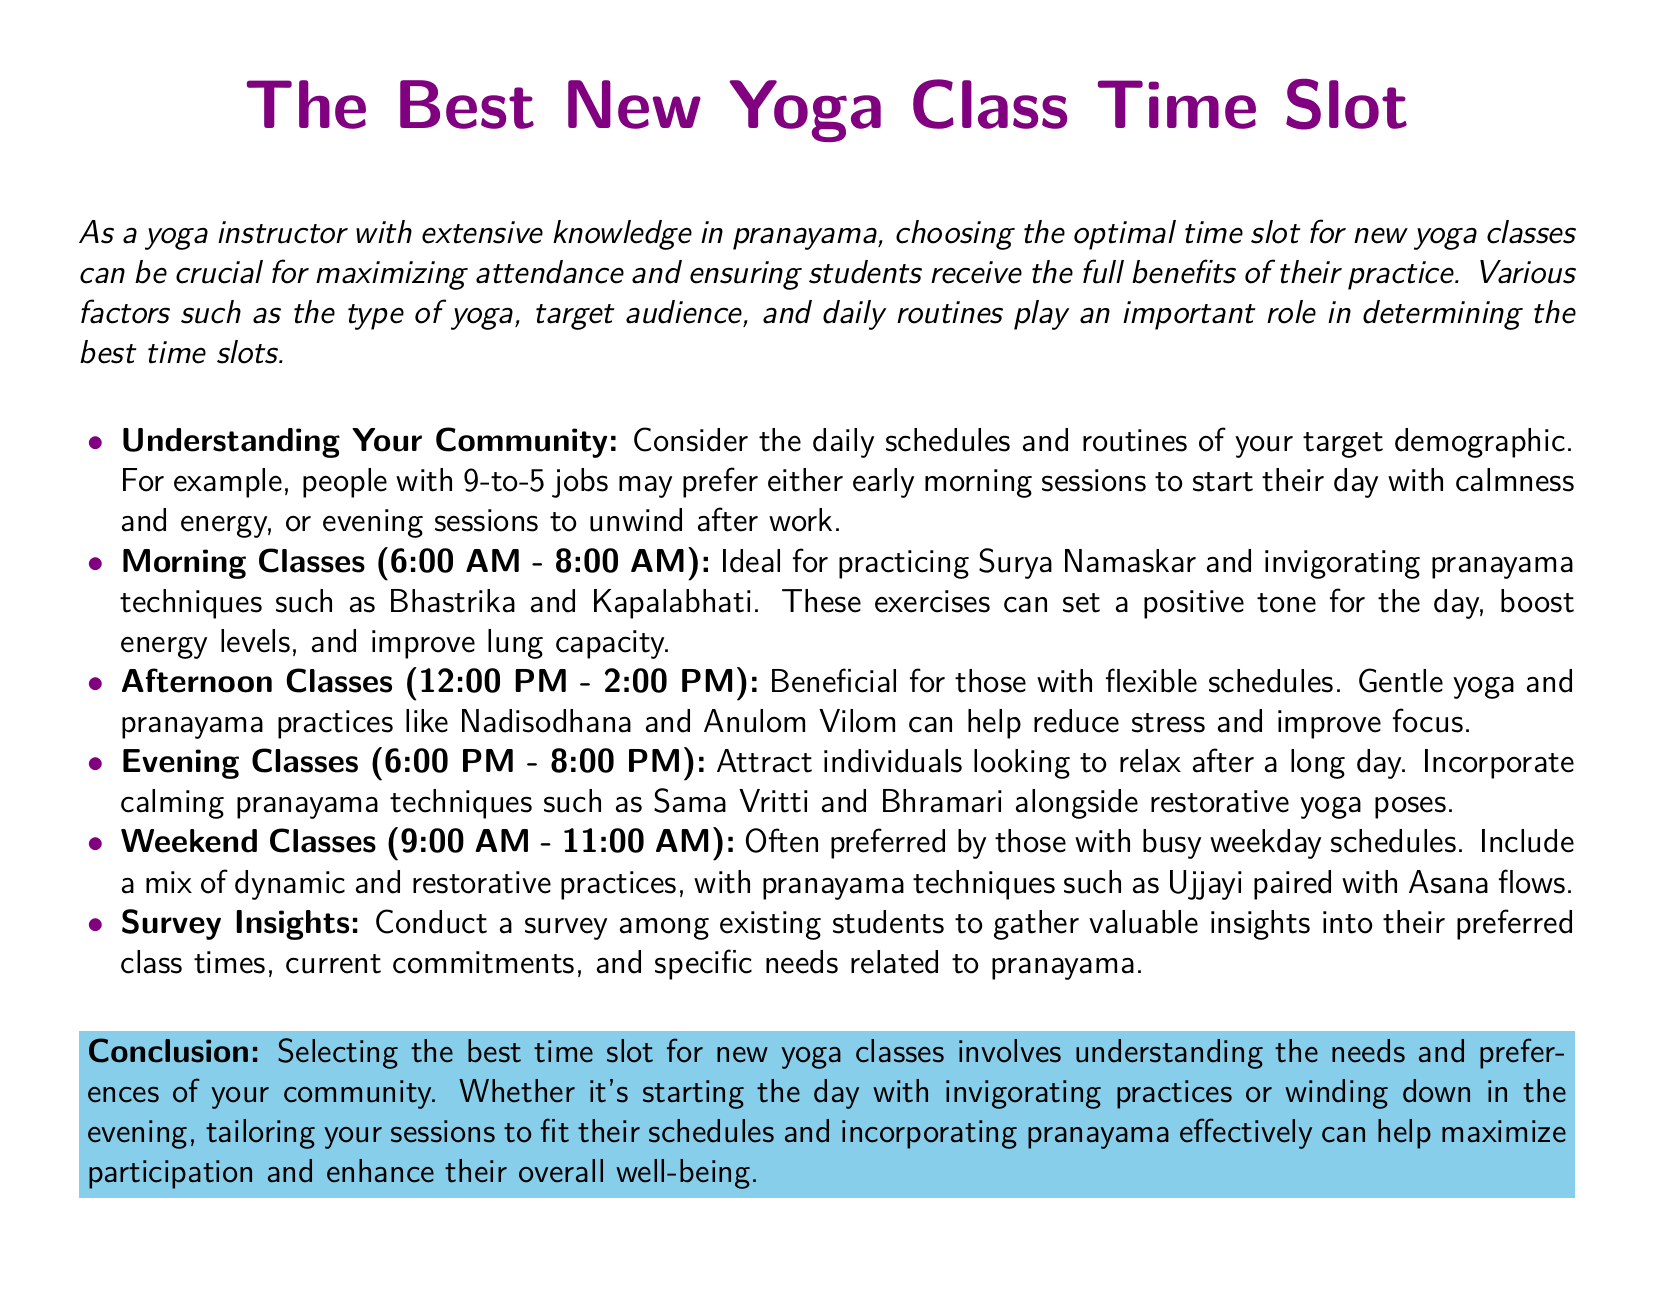What is the title of the document? The title is prominent and is displayed at the beginning of the document, indicating the subject matter.
Answer: The Best New Yoga Class Time Slot What are the morning class hours? The document specifies the time slot for morning classes clearly.
Answer: 6:00 AM - 8:00 AM Which pranayama technique is mentioned for evening classes? The document refers to specific pranayama techniques for different class times, including those for the evening.
Answer: Sama Vritti and Bhramari What type of yoga is suggested for afternoon classes? The document categorizes yoga types for different times, reflecting the needs of attendees.
Answer: Gentle yoga What is the preferred time for weekend classes? This information is highlighted to address a specific demographic's needs in the document.
Answer: 9:00 AM - 11:00 AM Why should instructors conduct a survey? The document emphasizes the importance of gathering feedback from students to improve class offerings.
Answer: To gather valuable insights What is a benefit of practicing yoga in the morning? The document outlines the advantages of morning sessions, including specific outcomes related to energy.
Answer: Boost energy levels How does the document suggest tailoring classes? The document suggests methods to personalize classes based on demographic preferences and schedules.
Answer: Incorporating pranayama effectively 